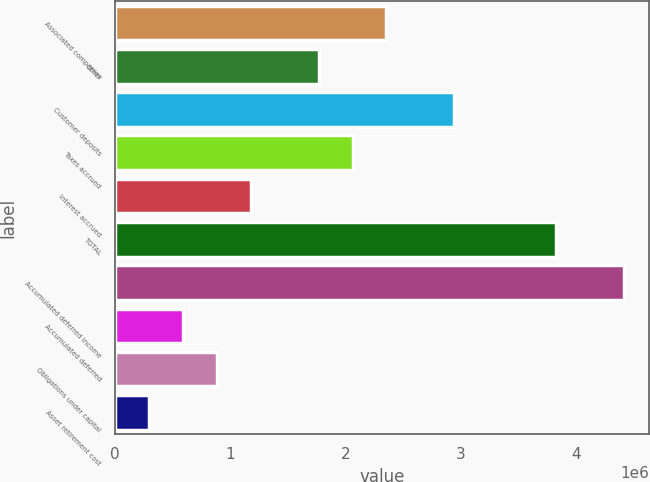Convert chart to OTSL. <chart><loc_0><loc_0><loc_500><loc_500><bar_chart><fcel>Associated companies<fcel>Other<fcel>Customer deposits<fcel>Taxes accrued<fcel>Interest accrued<fcel>TOTAL<fcel>Accumulated deferred income<fcel>Accumulated deferred<fcel>Obligations under capital<fcel>Asset retirement cost<nl><fcel>2.35485e+06<fcel>1.76631e+06<fcel>2.94339e+06<fcel>2.06058e+06<fcel>1.17777e+06<fcel>3.82621e+06<fcel>4.41475e+06<fcel>589231<fcel>883501<fcel>294960<nl></chart> 